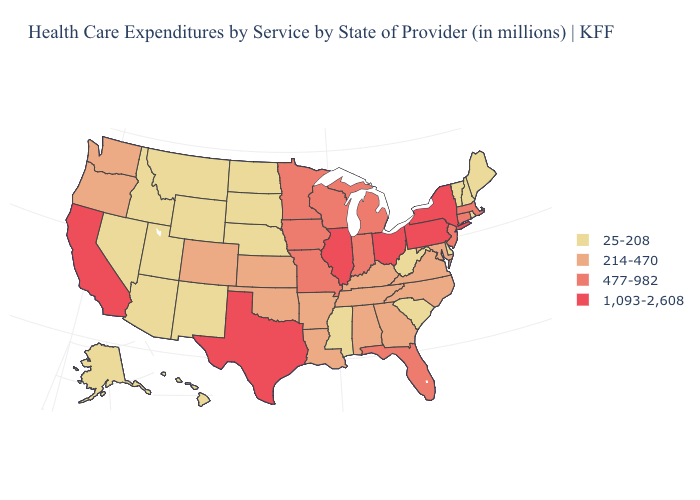What is the lowest value in the USA?
Quick response, please. 25-208. What is the value of Missouri?
Quick response, please. 477-982. What is the value of Idaho?
Answer briefly. 25-208. What is the highest value in the Northeast ?
Be succinct. 1,093-2,608. What is the value of Michigan?
Be succinct. 477-982. Which states have the lowest value in the USA?
Quick response, please. Alaska, Arizona, Delaware, Hawaii, Idaho, Maine, Mississippi, Montana, Nebraska, Nevada, New Hampshire, New Mexico, North Dakota, Rhode Island, South Carolina, South Dakota, Utah, Vermont, West Virginia, Wyoming. What is the value of Missouri?
Be succinct. 477-982. Which states have the lowest value in the MidWest?
Quick response, please. Nebraska, North Dakota, South Dakota. Does the first symbol in the legend represent the smallest category?
Give a very brief answer. Yes. Name the states that have a value in the range 1,093-2,608?
Short answer required. California, Illinois, New York, Ohio, Pennsylvania, Texas. What is the value of Arizona?
Give a very brief answer. 25-208. What is the value of Colorado?
Answer briefly. 214-470. Which states have the lowest value in the USA?
Answer briefly. Alaska, Arizona, Delaware, Hawaii, Idaho, Maine, Mississippi, Montana, Nebraska, Nevada, New Hampshire, New Mexico, North Dakota, Rhode Island, South Carolina, South Dakota, Utah, Vermont, West Virginia, Wyoming. What is the lowest value in the West?
Quick response, please. 25-208. Does Florida have the lowest value in the USA?
Short answer required. No. 